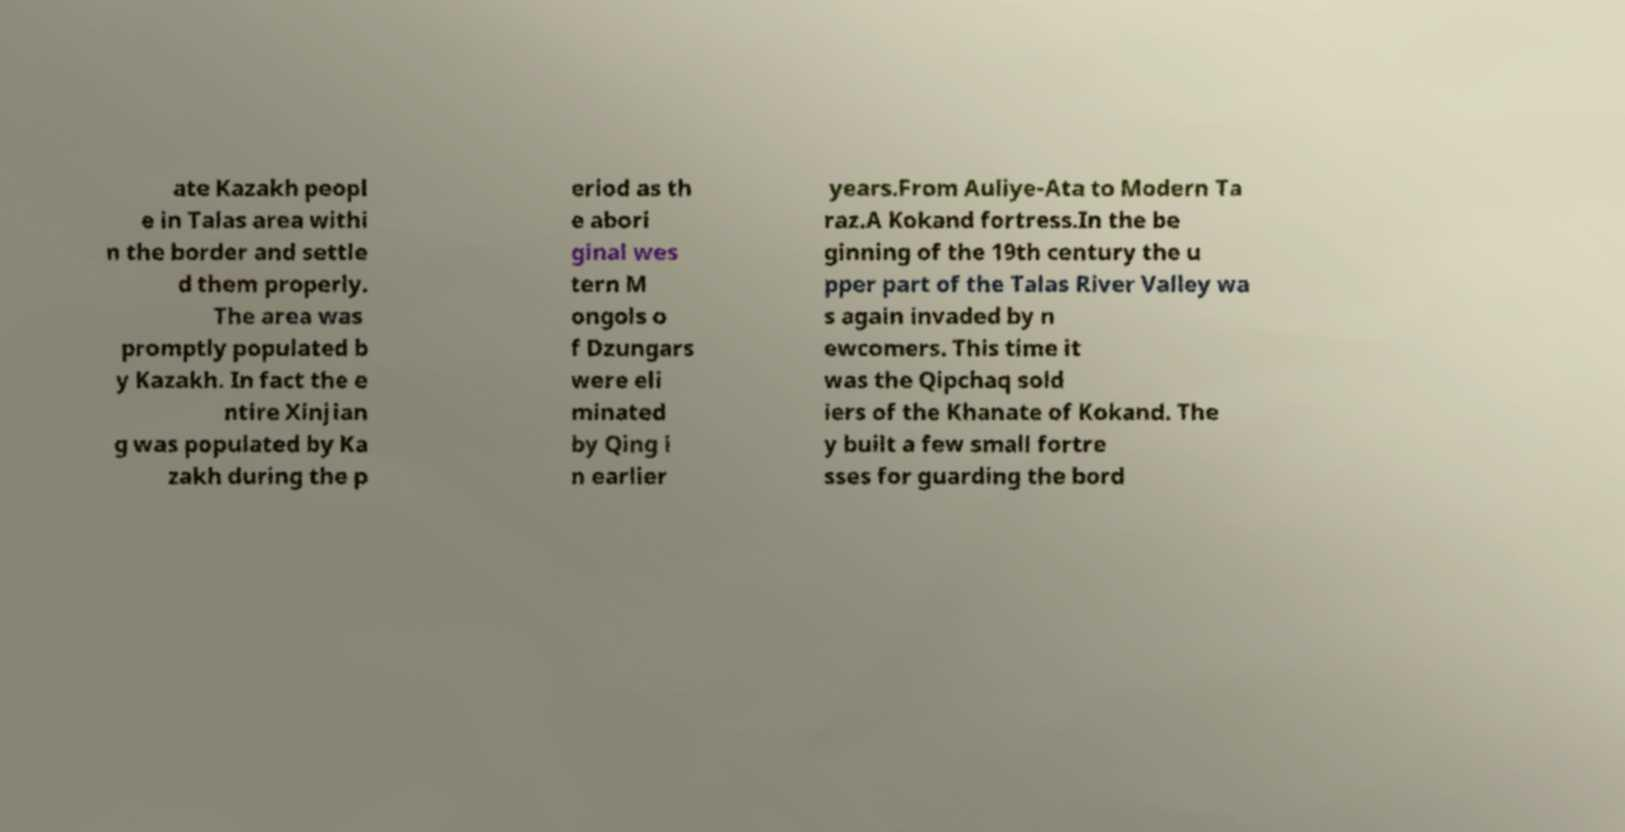For documentation purposes, I need the text within this image transcribed. Could you provide that? ate Kazakh peopl e in Talas area withi n the border and settle d them properly. The area was promptly populated b y Kazakh. In fact the e ntire Xinjian g was populated by Ka zakh during the p eriod as th e abori ginal wes tern M ongols o f Dzungars were eli minated by Qing i n earlier years.From Auliye-Ata to Modern Ta raz.A Kokand fortress.In the be ginning of the 19th century the u pper part of the Talas River Valley wa s again invaded by n ewcomers. This time it was the Qipchaq sold iers of the Khanate of Kokand. The y built a few small fortre sses for guarding the bord 